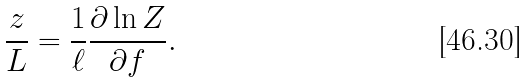Convert formula to latex. <formula><loc_0><loc_0><loc_500><loc_500>\frac { z } { L } = \frac { 1 } { \ell } \frac { \partial \ln Z } { \partial f } .</formula> 